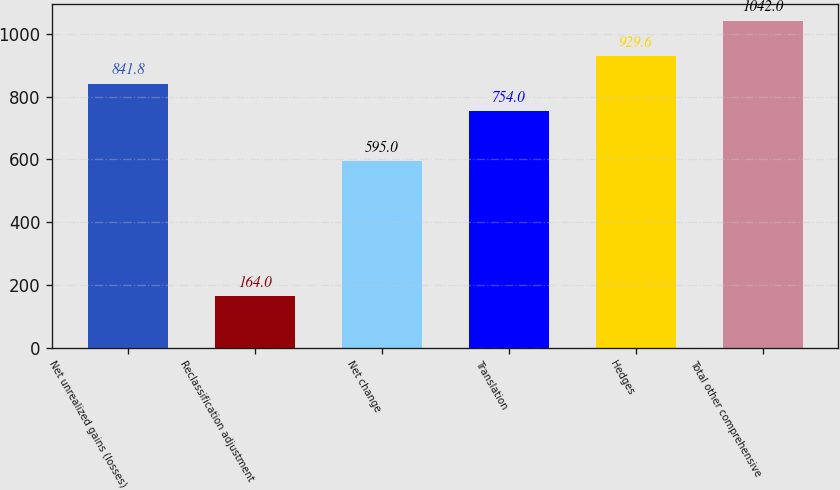Convert chart. <chart><loc_0><loc_0><loc_500><loc_500><bar_chart><fcel>Net unrealized gains (losses)<fcel>Reclassification adjustment<fcel>Net change<fcel>Translation<fcel>Hedges<fcel>Total other comprehensive<nl><fcel>841.8<fcel>164<fcel>595<fcel>754<fcel>929.6<fcel>1042<nl></chart> 